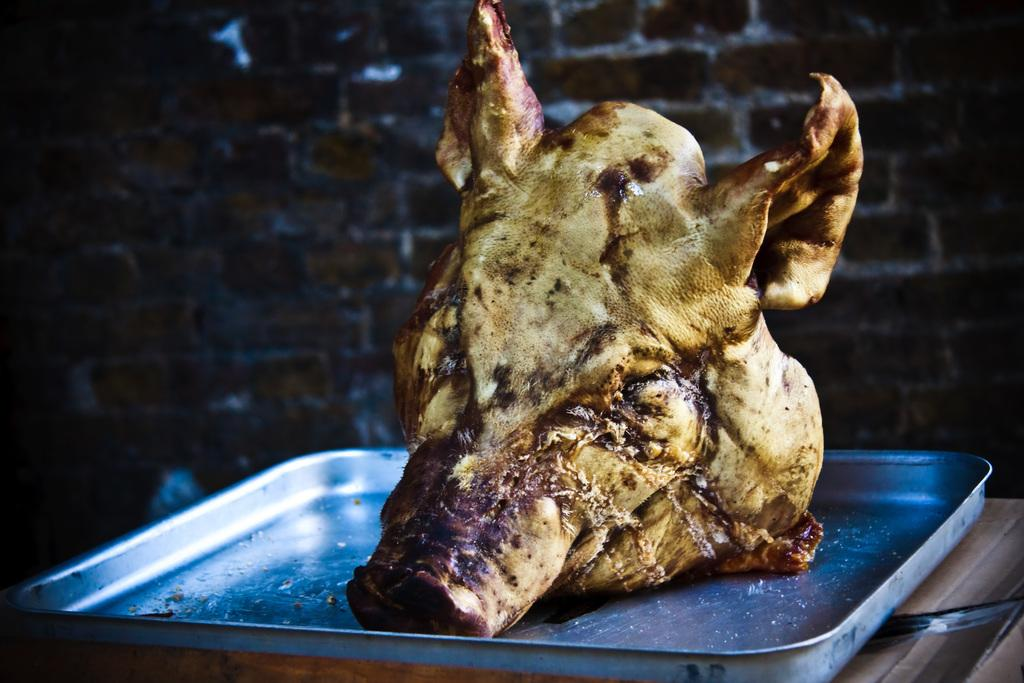What type of dish is featured in the image? There is a pork dish in the image. What is the pork dish placed on? The pork dish is on a silver plate. What can be seen in the background of the image? There is a wall in the background of the image. How much butter is on the passenger's seat in the image? There is no passenger or butter present in the image; it features a pork dish on a silver plate with a wall in the background. 